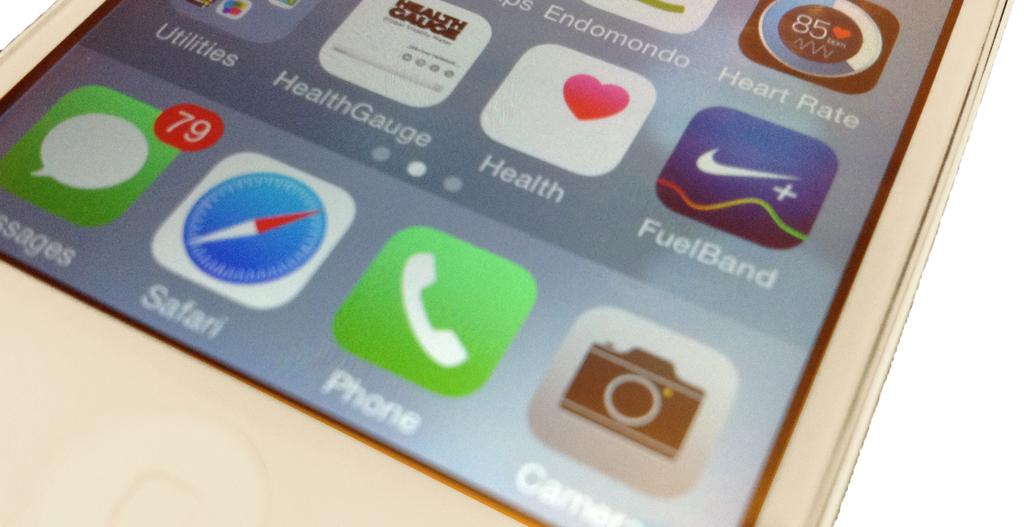<image>
Present a compact description of the photo's key features. white iphone showing several apps including safari, healthgauge, and fuelband 